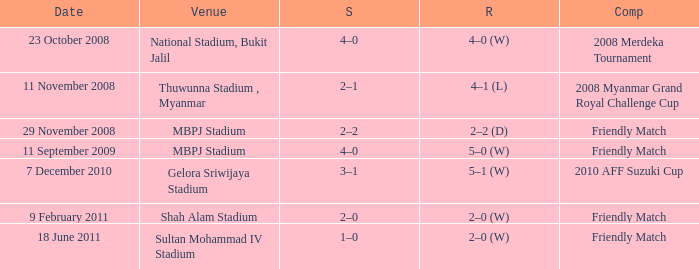What is the Venue of the Competition with a Result of 2–2 (d)? MBPJ Stadium. 